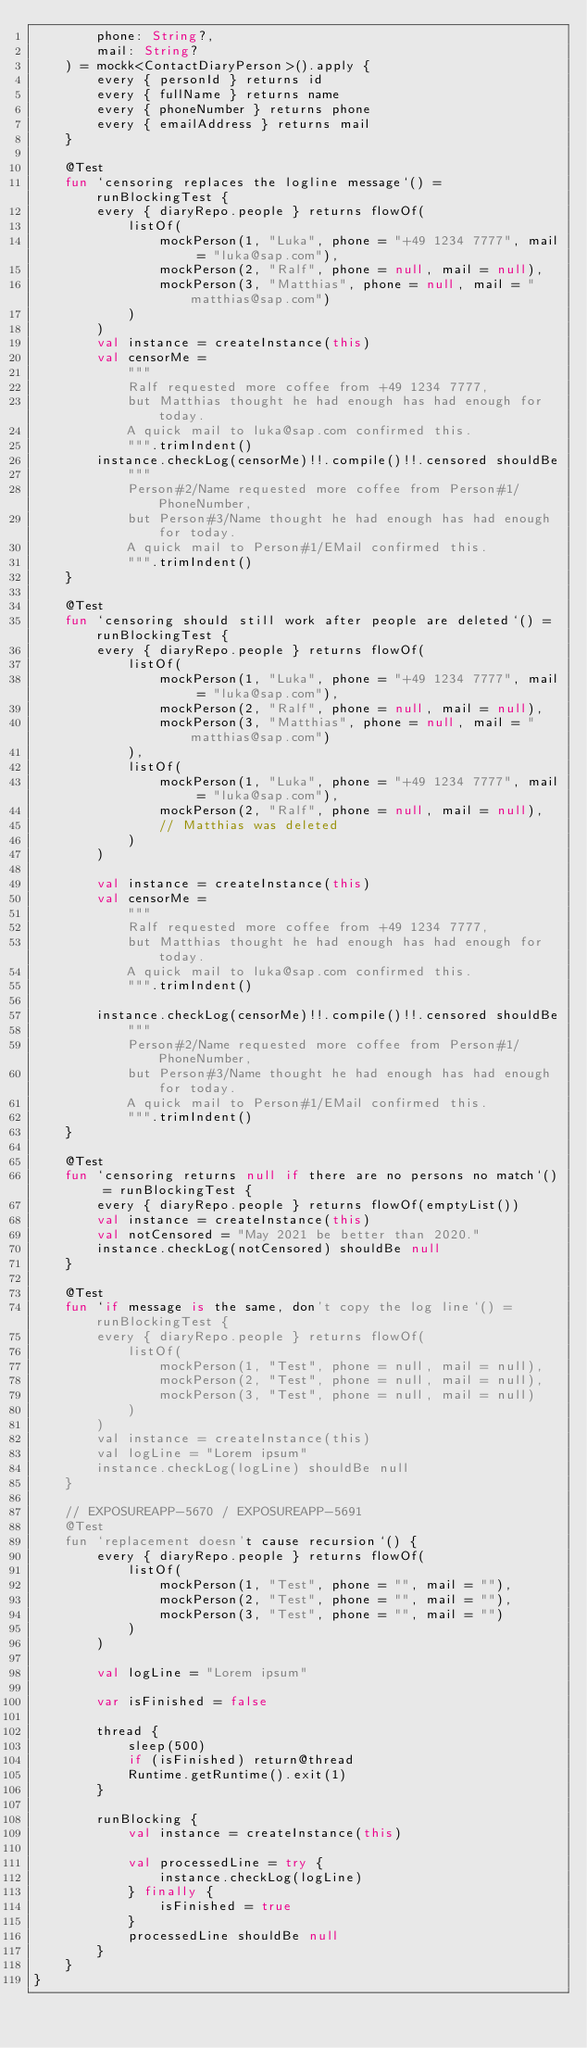Convert code to text. <code><loc_0><loc_0><loc_500><loc_500><_Kotlin_>        phone: String?,
        mail: String?
    ) = mockk<ContactDiaryPerson>().apply {
        every { personId } returns id
        every { fullName } returns name
        every { phoneNumber } returns phone
        every { emailAddress } returns mail
    }

    @Test
    fun `censoring replaces the logline message`() = runBlockingTest {
        every { diaryRepo.people } returns flowOf(
            listOf(
                mockPerson(1, "Luka", phone = "+49 1234 7777", mail = "luka@sap.com"),
                mockPerson(2, "Ralf", phone = null, mail = null),
                mockPerson(3, "Matthias", phone = null, mail = "matthias@sap.com")
            )
        )
        val instance = createInstance(this)
        val censorMe =
            """
            Ralf requested more coffee from +49 1234 7777,
            but Matthias thought he had enough has had enough for today.
            A quick mail to luka@sap.com confirmed this.
            """.trimIndent()
        instance.checkLog(censorMe)!!.compile()!!.censored shouldBe
            """
            Person#2/Name requested more coffee from Person#1/PhoneNumber,
            but Person#3/Name thought he had enough has had enough for today.
            A quick mail to Person#1/EMail confirmed this.
            """.trimIndent()
    }

    @Test
    fun `censoring should still work after people are deleted`() = runBlockingTest {
        every { diaryRepo.people } returns flowOf(
            listOf(
                mockPerson(1, "Luka", phone = "+49 1234 7777", mail = "luka@sap.com"),
                mockPerson(2, "Ralf", phone = null, mail = null),
                mockPerson(3, "Matthias", phone = null, mail = "matthias@sap.com")
            ),
            listOf(
                mockPerson(1, "Luka", phone = "+49 1234 7777", mail = "luka@sap.com"),
                mockPerson(2, "Ralf", phone = null, mail = null),
                // Matthias was deleted
            )
        )

        val instance = createInstance(this)
        val censorMe =
            """
            Ralf requested more coffee from +49 1234 7777,
            but Matthias thought he had enough has had enough for today.
            A quick mail to luka@sap.com confirmed this.
            """.trimIndent()

        instance.checkLog(censorMe)!!.compile()!!.censored shouldBe
            """
            Person#2/Name requested more coffee from Person#1/PhoneNumber,
            but Person#3/Name thought he had enough has had enough for today.
            A quick mail to Person#1/EMail confirmed this.
            """.trimIndent()
    }

    @Test
    fun `censoring returns null if there are no persons no match`() = runBlockingTest {
        every { diaryRepo.people } returns flowOf(emptyList())
        val instance = createInstance(this)
        val notCensored = "May 2021 be better than 2020."
        instance.checkLog(notCensored) shouldBe null
    }

    @Test
    fun `if message is the same, don't copy the log line`() = runBlockingTest {
        every { diaryRepo.people } returns flowOf(
            listOf(
                mockPerson(1, "Test", phone = null, mail = null),
                mockPerson(2, "Test", phone = null, mail = null),
                mockPerson(3, "Test", phone = null, mail = null)
            )
        )
        val instance = createInstance(this)
        val logLine = "Lorem ipsum"
        instance.checkLog(logLine) shouldBe null
    }

    // EXPOSUREAPP-5670 / EXPOSUREAPP-5691
    @Test
    fun `replacement doesn't cause recursion`() {
        every { diaryRepo.people } returns flowOf(
            listOf(
                mockPerson(1, "Test", phone = "", mail = ""),
                mockPerson(2, "Test", phone = "", mail = ""),
                mockPerson(3, "Test", phone = "", mail = "")
            )
        )

        val logLine = "Lorem ipsum"

        var isFinished = false

        thread {
            sleep(500)
            if (isFinished) return@thread
            Runtime.getRuntime().exit(1)
        }

        runBlocking {
            val instance = createInstance(this)

            val processedLine = try {
                instance.checkLog(logLine)
            } finally {
                isFinished = true
            }
            processedLine shouldBe null
        }
    }
}
</code> 